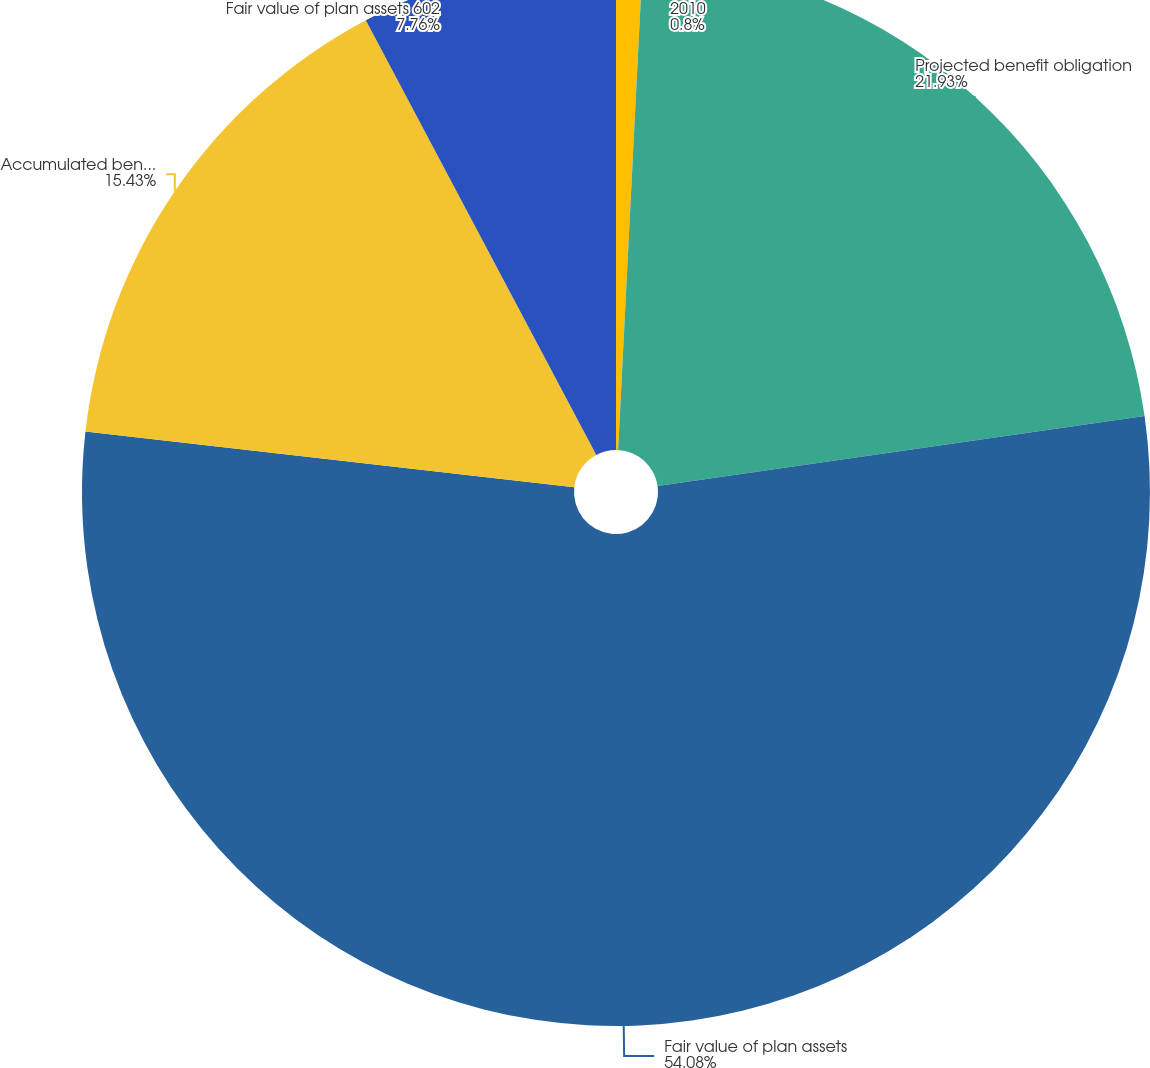Convert chart. <chart><loc_0><loc_0><loc_500><loc_500><pie_chart><fcel>2010<fcel>Projected benefit obligation<fcel>Fair value of plan assets<fcel>Accumulated benefit obligation<fcel>Fair value of plan assets 602<nl><fcel>0.8%<fcel>21.93%<fcel>54.08%<fcel>15.43%<fcel>7.76%<nl></chart> 